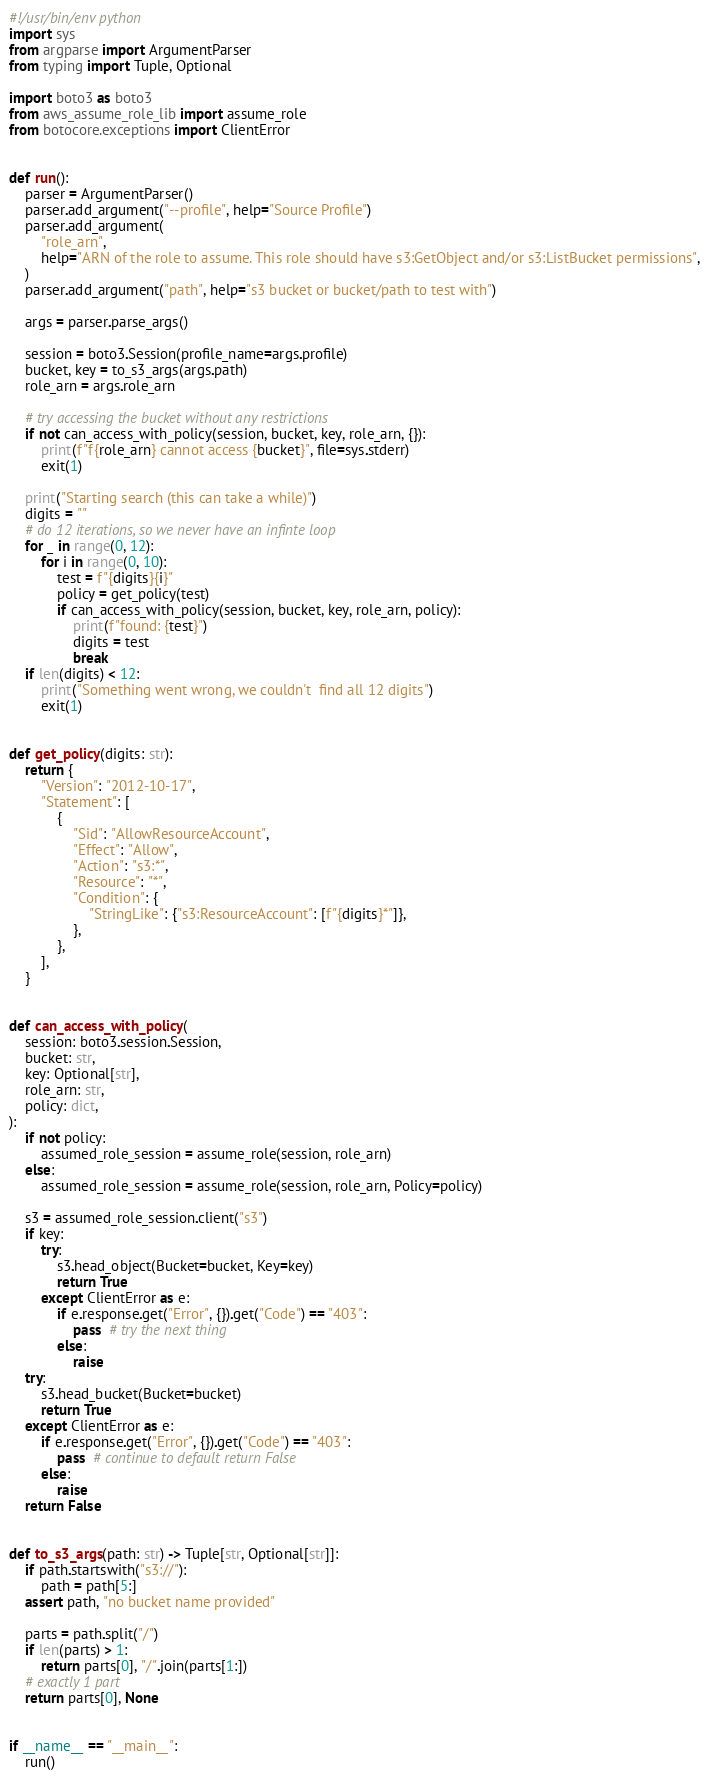Convert code to text. <code><loc_0><loc_0><loc_500><loc_500><_Python_>#!/usr/bin/env python
import sys
from argparse import ArgumentParser
from typing import Tuple, Optional

import boto3 as boto3
from aws_assume_role_lib import assume_role
from botocore.exceptions import ClientError


def run():
    parser = ArgumentParser()
    parser.add_argument("--profile", help="Source Profile")
    parser.add_argument(
        "role_arn",
        help="ARN of the role to assume. This role should have s3:GetObject and/or s3:ListBucket permissions",
    )
    parser.add_argument("path", help="s3 bucket or bucket/path to test with")

    args = parser.parse_args()

    session = boto3.Session(profile_name=args.profile)
    bucket, key = to_s3_args(args.path)
    role_arn = args.role_arn

    # try accessing the bucket without any restrictions
    if not can_access_with_policy(session, bucket, key, role_arn, {}):
        print(f"f{role_arn} cannot access {bucket}", file=sys.stderr)
        exit(1)

    print("Starting search (this can take a while)")
    digits = ""
    # do 12 iterations, so we never have an infinte loop
    for _ in range(0, 12):
        for i in range(0, 10):
            test = f"{digits}{i}"
            policy = get_policy(test)
            if can_access_with_policy(session, bucket, key, role_arn, policy):
                print(f"found: {test}")
                digits = test
                break
    if len(digits) < 12:
        print("Something went wrong, we couldn't  find all 12 digits")
        exit(1)


def get_policy(digits: str):
    return {
        "Version": "2012-10-17",
        "Statement": [
            {
                "Sid": "AllowResourceAccount",
                "Effect": "Allow",
                "Action": "s3:*",
                "Resource": "*",
                "Condition": {
                    "StringLike": {"s3:ResourceAccount": [f"{digits}*"]},
                },
            },
        ],
    }


def can_access_with_policy(
    session: boto3.session.Session,
    bucket: str,
    key: Optional[str],
    role_arn: str,
    policy: dict,
):
    if not policy:
        assumed_role_session = assume_role(session, role_arn)
    else:
        assumed_role_session = assume_role(session, role_arn, Policy=policy)

    s3 = assumed_role_session.client("s3")
    if key:
        try:
            s3.head_object(Bucket=bucket, Key=key)
            return True
        except ClientError as e:
            if e.response.get("Error", {}).get("Code") == "403":
                pass  # try the next thing
            else:
                raise
    try:
        s3.head_bucket(Bucket=bucket)
        return True
    except ClientError as e:
        if e.response.get("Error", {}).get("Code") == "403":
            pass  # continue to default return False
        else:
            raise
    return False


def to_s3_args(path: str) -> Tuple[str, Optional[str]]:
    if path.startswith("s3://"):
        path = path[5:]
    assert path, "no bucket name provided"

    parts = path.split("/")
    if len(parts) > 1:
        return parts[0], "/".join(parts[1:])
    # exactly 1 part
    return parts[0], None


if __name__ == "__main__":
    run()
</code> 